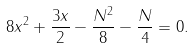<formula> <loc_0><loc_0><loc_500><loc_500>8 x ^ { 2 } + \frac { 3 x } { 2 } - \frac { N ^ { 2 } } { 8 } - \frac { N } { 4 } = 0 .</formula> 